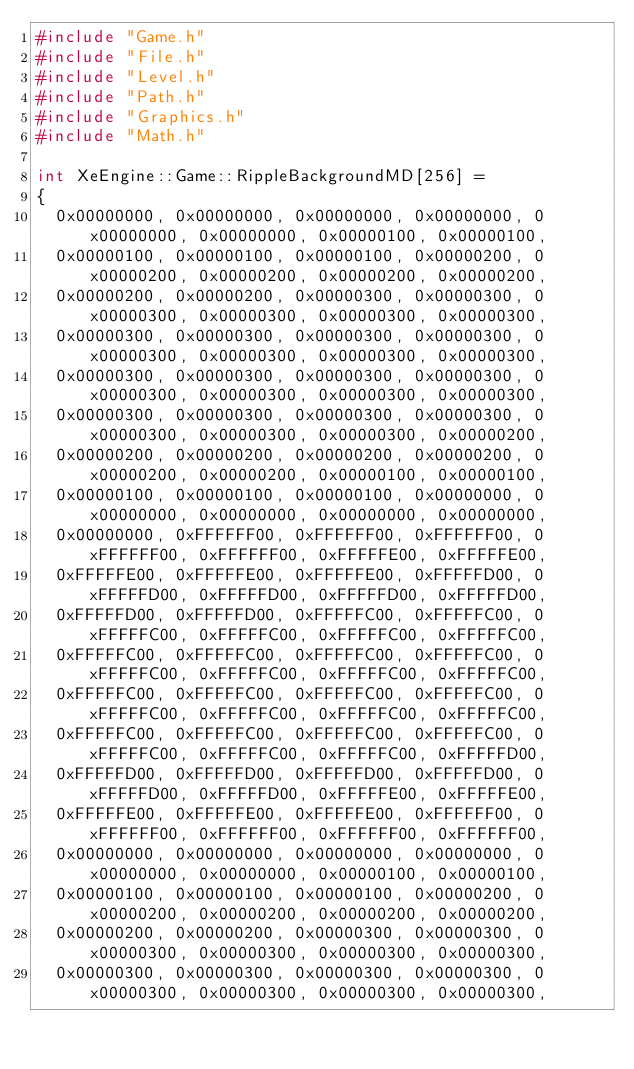Convert code to text. <code><loc_0><loc_0><loc_500><loc_500><_C++_>#include "Game.h"
#include "File.h"
#include "Level.h"
#include "Path.h"
#include "Graphics.h"
#include "Math.h"

int XeEngine::Game::RippleBackgroundMD[256] =
{
	0x00000000, 0x00000000, 0x00000000, 0x00000000, 0x00000000, 0x00000000, 0x00000100, 0x00000100, 
	0x00000100, 0x00000100, 0x00000100, 0x00000200, 0x00000200, 0x00000200, 0x00000200, 0x00000200, 
	0x00000200, 0x00000200, 0x00000300, 0x00000300, 0x00000300, 0x00000300, 0x00000300, 0x00000300, 
	0x00000300, 0x00000300, 0x00000300, 0x00000300, 0x00000300, 0x00000300, 0x00000300, 0x00000300, 
	0x00000300, 0x00000300, 0x00000300, 0x00000300, 0x00000300, 0x00000300, 0x00000300, 0x00000300, 
	0x00000300, 0x00000300, 0x00000300, 0x00000300, 0x00000300, 0x00000300, 0x00000300, 0x00000200, 
	0x00000200, 0x00000200, 0x00000200, 0x00000200, 0x00000200, 0x00000200, 0x00000100, 0x00000100, 
	0x00000100, 0x00000100, 0x00000100, 0x00000000, 0x00000000, 0x00000000, 0x00000000, 0x00000000, 
	0x00000000, 0xFFFFFF00, 0xFFFFFF00, 0xFFFFFF00, 0xFFFFFF00, 0xFFFFFF00, 0xFFFFFE00, 0xFFFFFE00, 
	0xFFFFFE00, 0xFFFFFE00, 0xFFFFFE00, 0xFFFFFD00, 0xFFFFFD00, 0xFFFFFD00, 0xFFFFFD00, 0xFFFFFD00, 
	0xFFFFFD00, 0xFFFFFD00, 0xFFFFFC00, 0xFFFFFC00, 0xFFFFFC00, 0xFFFFFC00, 0xFFFFFC00, 0xFFFFFC00, 
	0xFFFFFC00, 0xFFFFFC00, 0xFFFFFC00, 0xFFFFFC00, 0xFFFFFC00, 0xFFFFFC00, 0xFFFFFC00, 0xFFFFFC00, 
	0xFFFFFC00, 0xFFFFFC00, 0xFFFFFC00, 0xFFFFFC00, 0xFFFFFC00, 0xFFFFFC00, 0xFFFFFC00, 0xFFFFFC00, 
	0xFFFFFC00, 0xFFFFFC00, 0xFFFFFC00, 0xFFFFFC00, 0xFFFFFC00, 0xFFFFFC00, 0xFFFFFC00, 0xFFFFFD00, 
	0xFFFFFD00, 0xFFFFFD00, 0xFFFFFD00, 0xFFFFFD00, 0xFFFFFD00, 0xFFFFFD00, 0xFFFFFE00, 0xFFFFFE00, 
	0xFFFFFE00, 0xFFFFFE00, 0xFFFFFE00, 0xFFFFFF00, 0xFFFFFF00, 0xFFFFFF00, 0xFFFFFF00, 0xFFFFFF00, 
	0x00000000, 0x00000000, 0x00000000, 0x00000000, 0x00000000, 0x00000000, 0x00000100, 0x00000100, 
	0x00000100, 0x00000100, 0x00000100, 0x00000200, 0x00000200, 0x00000200, 0x00000200, 0x00000200, 
	0x00000200, 0x00000200, 0x00000300, 0x00000300, 0x00000300, 0x00000300, 0x00000300, 0x00000300, 
	0x00000300, 0x00000300, 0x00000300, 0x00000300, 0x00000300, 0x00000300, 0x00000300, 0x00000300, </code> 